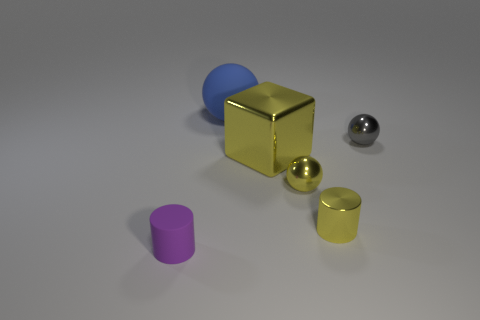Subtract all tiny yellow metal balls. How many balls are left? 2 Add 1 tiny purple metal cylinders. How many objects exist? 7 Subtract all purple cylinders. How many cylinders are left? 1 Subtract all cylinders. How many objects are left? 4 Subtract all gray cubes. How many purple cylinders are left? 1 Subtract all large purple things. Subtract all big yellow metal things. How many objects are left? 5 Add 6 large things. How many large things are left? 8 Add 1 tiny gray things. How many tiny gray things exist? 2 Subtract 0 brown cylinders. How many objects are left? 6 Subtract 1 blocks. How many blocks are left? 0 